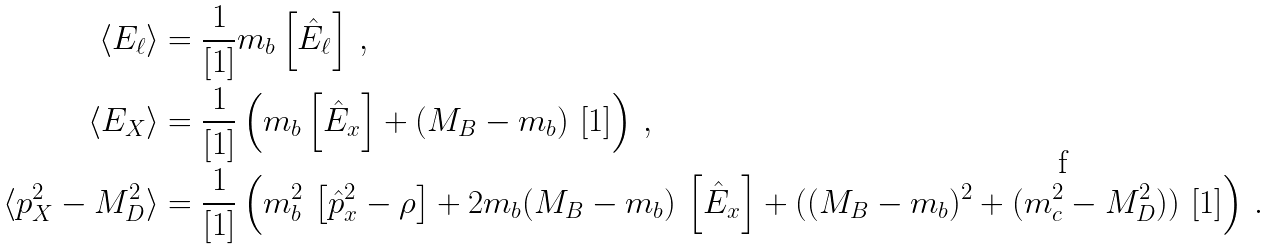<formula> <loc_0><loc_0><loc_500><loc_500>\langle E _ { \ell } \rangle & = \frac { 1 } { \left [ 1 \right ] } m _ { b } \left [ \hat { E } _ { \ell } \right ] \, , \\ \langle E _ { X } \rangle & = \frac { 1 } { \left [ 1 \right ] } \left ( m _ { b } \left [ { \hat { E } } _ { x } \right ] + ( M _ { B } - m _ { b } ) \, \left [ 1 \right ] \right ) \, , \\ \langle p _ { X } ^ { 2 } - M _ { D } ^ { 2 } \rangle & = \frac { 1 } { \left [ 1 \right ] } \left ( m _ { b } ^ { 2 } \, \left [ \hat { p } _ { x } ^ { 2 } - \rho \right ] + 2 m _ { b } ( M _ { B } - m _ { b } ) \, \left [ { \hat { E } } _ { x } \right ] + ( ( M _ { B } - m _ { b } ) ^ { 2 } + ( m _ { c } ^ { 2 } - M _ { D } ^ { 2 } ) ) \, \left [ 1 \right ] \right ) \, .</formula> 